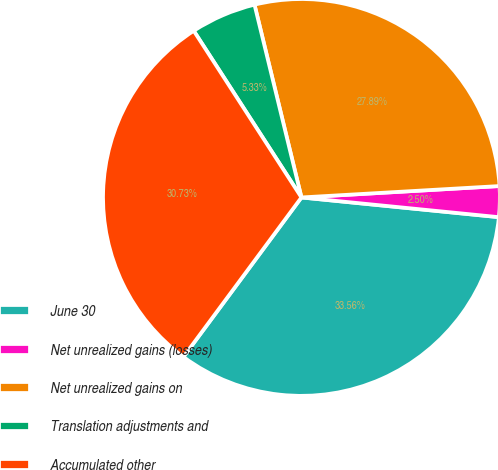Convert chart to OTSL. <chart><loc_0><loc_0><loc_500><loc_500><pie_chart><fcel>June 30<fcel>Net unrealized gains (losses)<fcel>Net unrealized gains on<fcel>Translation adjustments and<fcel>Accumulated other<nl><fcel>33.56%<fcel>2.5%<fcel>27.89%<fcel>5.33%<fcel>30.73%<nl></chart> 